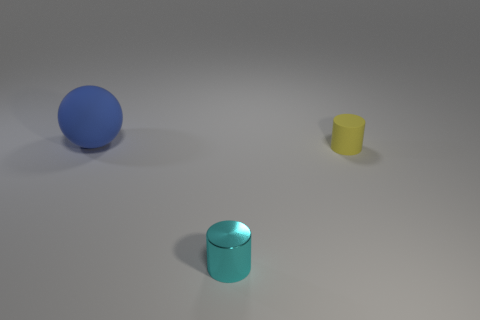Add 2 small cyan shiny objects. How many objects exist? 5 Subtract all cylinders. How many objects are left? 1 Subtract 1 blue spheres. How many objects are left? 2 Subtract all small green blocks. Subtract all large blue matte spheres. How many objects are left? 2 Add 3 blue objects. How many blue objects are left? 4 Add 1 cylinders. How many cylinders exist? 3 